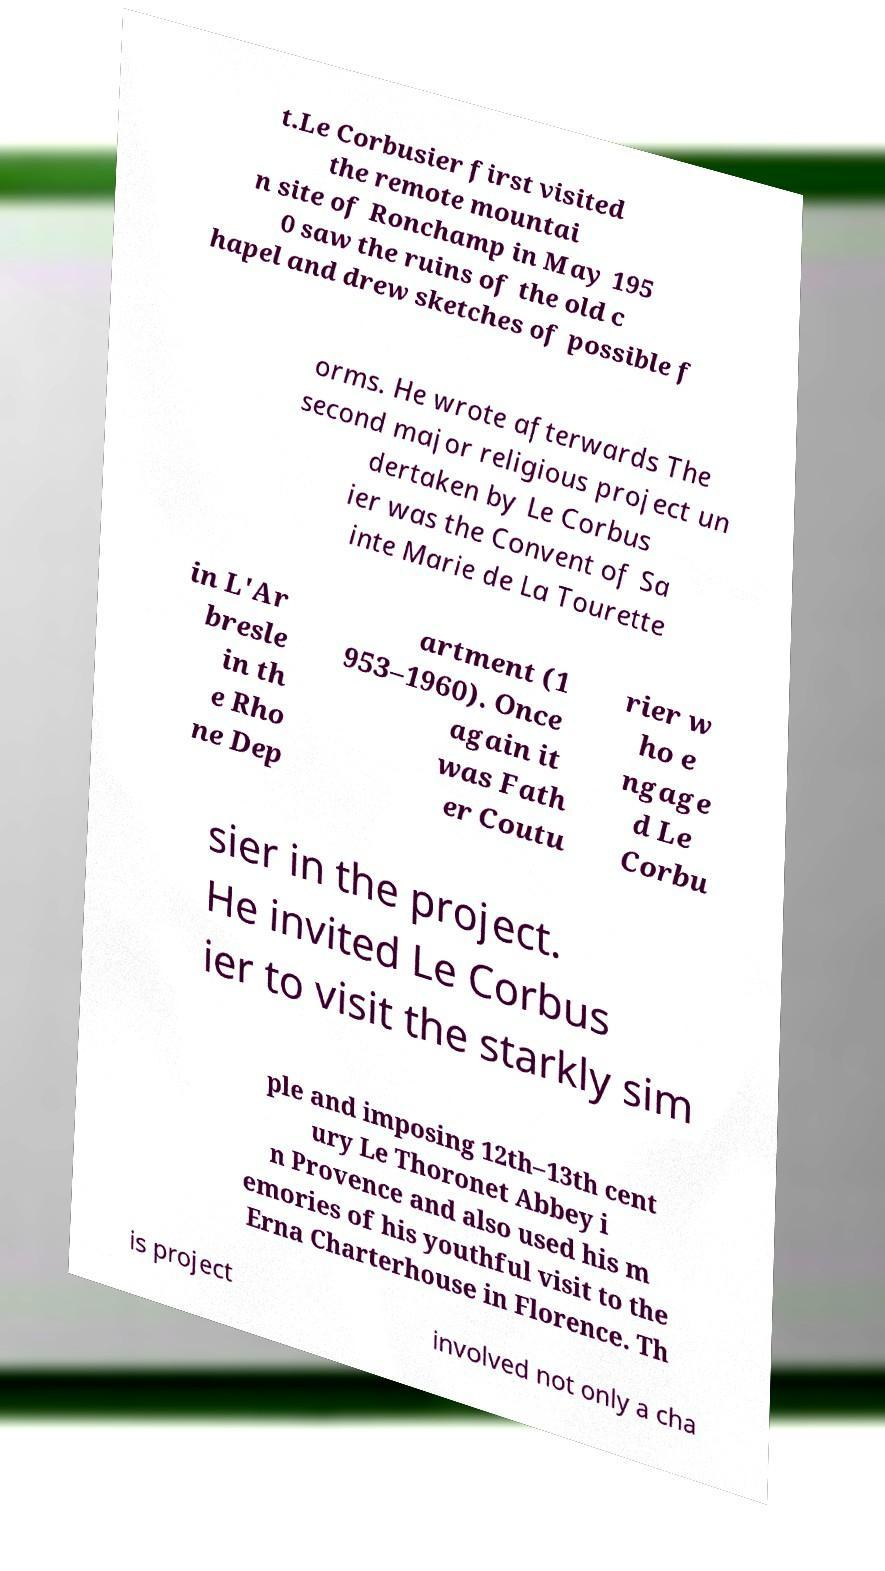Please identify and transcribe the text found in this image. t.Le Corbusier first visited the remote mountai n site of Ronchamp in May 195 0 saw the ruins of the old c hapel and drew sketches of possible f orms. He wrote afterwards The second major religious project un dertaken by Le Corbus ier was the Convent of Sa inte Marie de La Tourette in L'Ar bresle in th e Rho ne Dep artment (1 953–1960). Once again it was Fath er Coutu rier w ho e ngage d Le Corbu sier in the project. He invited Le Corbus ier to visit the starkly sim ple and imposing 12th–13th cent ury Le Thoronet Abbey i n Provence and also used his m emories of his youthful visit to the Erna Charterhouse in Florence. Th is project involved not only a cha 